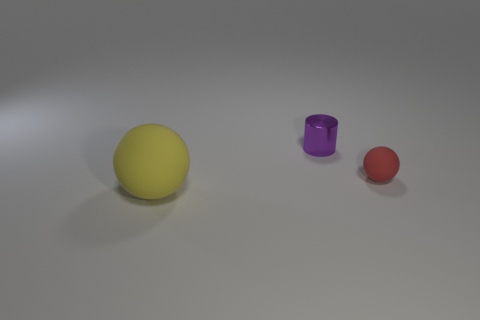Is there any other thing that is the same size as the yellow object?
Your answer should be compact. No. There is a tiny thing in front of the purple cylinder; what shape is it?
Offer a very short reply. Sphere. Is there a large gray cylinder made of the same material as the red thing?
Offer a very short reply. No. There is a sphere that is on the right side of the yellow object; is it the same color as the small cylinder?
Make the answer very short. No. The purple shiny cylinder is what size?
Your response must be concise. Small. There is a matte object that is behind the matte object on the left side of the small purple metallic cylinder; is there a large sphere that is left of it?
Provide a short and direct response. Yes. How many yellow spheres are right of the large rubber ball?
Keep it short and to the point. 0. What number of big rubber spheres are the same color as the cylinder?
Offer a terse response. 0. How many objects are either large yellow matte balls that are in front of the tiny sphere or things on the left side of the tiny red sphere?
Offer a terse response. 2. Are there more yellow balls than tiny yellow balls?
Offer a terse response. Yes. 